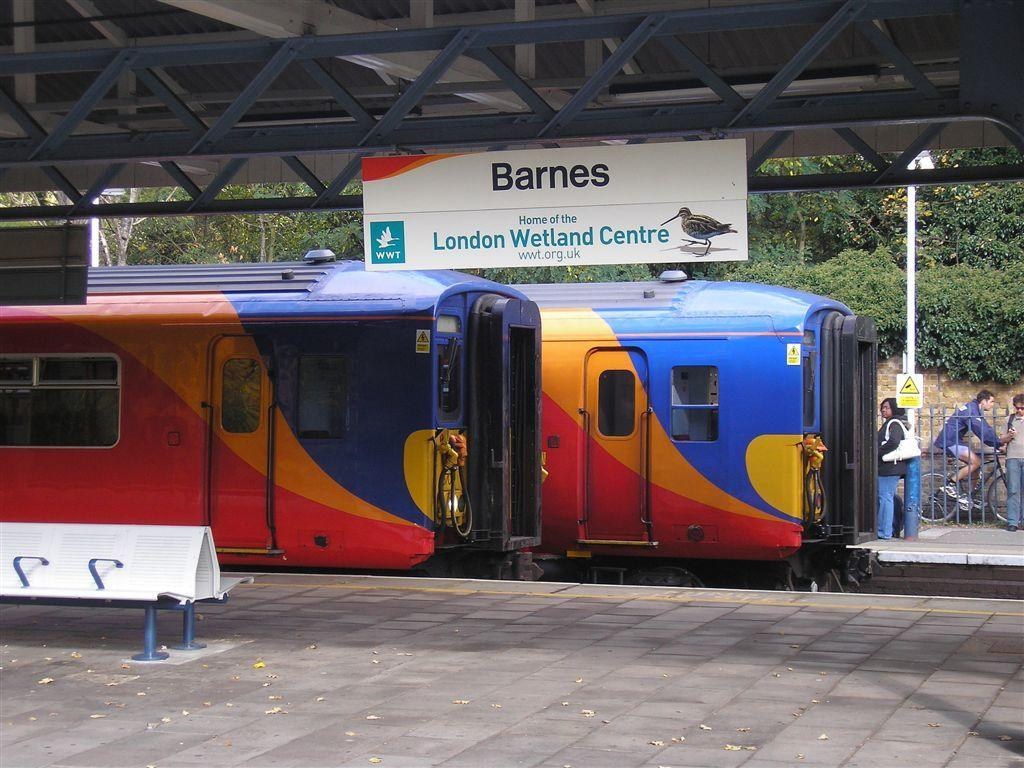<image>
Provide a brief description of the given image. Two trains are at the Barnes station, home of the London Wetlands Centre. 